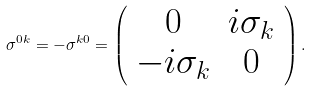Convert formula to latex. <formula><loc_0><loc_0><loc_500><loc_500>\sigma ^ { 0 k } = - \sigma ^ { k 0 } = \left ( \begin{array} { * { 2 } { c } } 0 & i \sigma _ { k } \\ - i \sigma _ { k } & 0 \end{array} \right ) .</formula> 